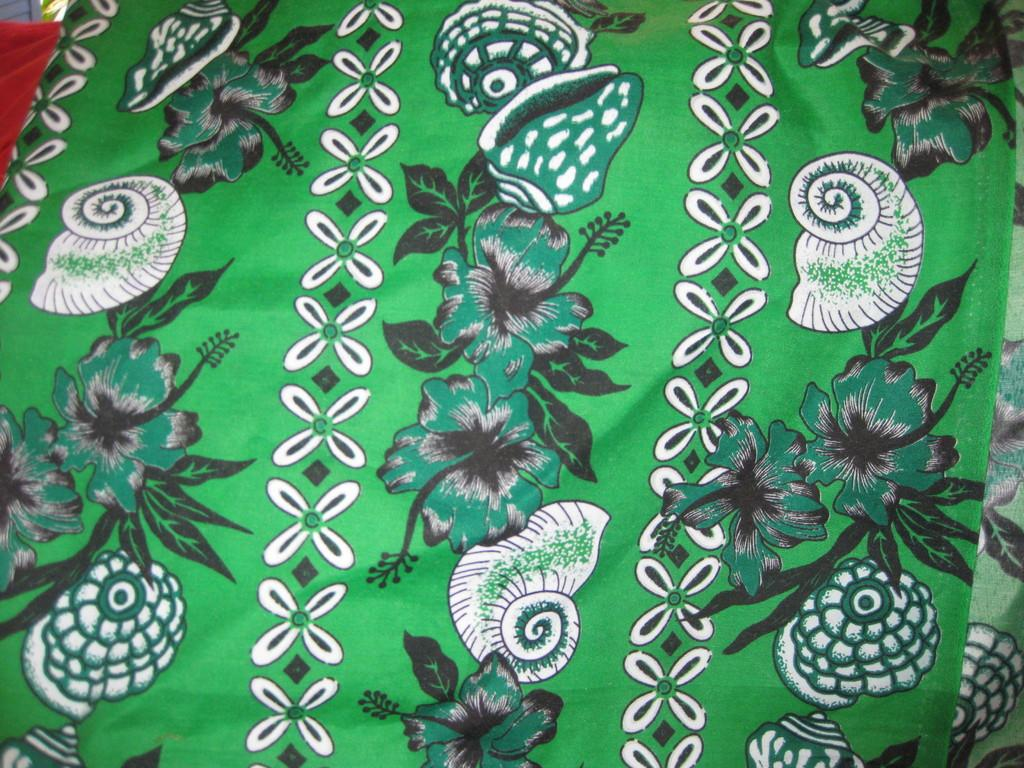What type of items can be seen in the image? There are clothes in the image. What colors are present on the clothes? The clothes have green, white, black, and red colors. What type of feast is being prepared on the canvas in the image? There is no canvas or feast present in the image; it only features clothes with different colors. 